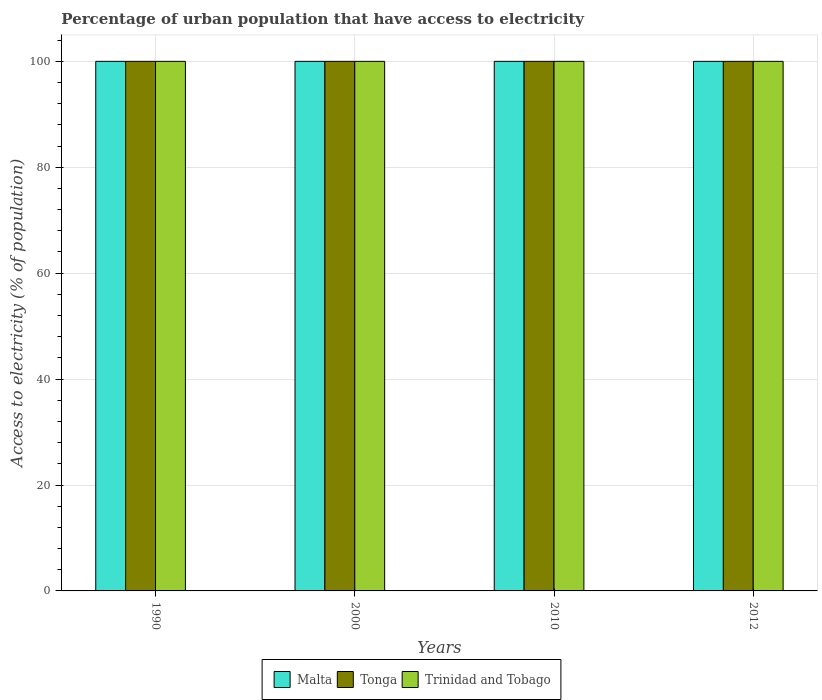How many different coloured bars are there?
Offer a very short reply. 3. What is the percentage of urban population that have access to electricity in Tonga in 1990?
Offer a very short reply. 100. Across all years, what is the maximum percentage of urban population that have access to electricity in Tonga?
Your answer should be very brief. 100. Across all years, what is the minimum percentage of urban population that have access to electricity in Tonga?
Make the answer very short. 100. In which year was the percentage of urban population that have access to electricity in Malta maximum?
Your response must be concise. 1990. What is the total percentage of urban population that have access to electricity in Trinidad and Tobago in the graph?
Provide a short and direct response. 400. In the year 1990, what is the difference between the percentage of urban population that have access to electricity in Tonga and percentage of urban population that have access to electricity in Malta?
Offer a terse response. 0. What is the ratio of the percentage of urban population that have access to electricity in Trinidad and Tobago in 1990 to that in 2000?
Provide a succinct answer. 1. Is the percentage of urban population that have access to electricity in Tonga in 1990 less than that in 2000?
Your answer should be compact. No. What is the difference between the highest and the second highest percentage of urban population that have access to electricity in Trinidad and Tobago?
Make the answer very short. 0. What is the difference between the highest and the lowest percentage of urban population that have access to electricity in Trinidad and Tobago?
Offer a terse response. 0. What does the 3rd bar from the left in 2000 represents?
Provide a short and direct response. Trinidad and Tobago. What does the 3rd bar from the right in 2012 represents?
Offer a very short reply. Malta. Is it the case that in every year, the sum of the percentage of urban population that have access to electricity in Trinidad and Tobago and percentage of urban population that have access to electricity in Tonga is greater than the percentage of urban population that have access to electricity in Malta?
Offer a very short reply. Yes. How many bars are there?
Your answer should be very brief. 12. Are all the bars in the graph horizontal?
Make the answer very short. No. How many years are there in the graph?
Your answer should be compact. 4. Does the graph contain any zero values?
Provide a short and direct response. No. How are the legend labels stacked?
Keep it short and to the point. Horizontal. What is the title of the graph?
Provide a short and direct response. Percentage of urban population that have access to electricity. Does "Low & middle income" appear as one of the legend labels in the graph?
Offer a terse response. No. What is the label or title of the Y-axis?
Ensure brevity in your answer.  Access to electricity (% of population). What is the Access to electricity (% of population) in Tonga in 1990?
Give a very brief answer. 100. What is the Access to electricity (% of population) of Trinidad and Tobago in 1990?
Your response must be concise. 100. What is the Access to electricity (% of population) in Malta in 2000?
Ensure brevity in your answer.  100. What is the Access to electricity (% of population) in Tonga in 2000?
Make the answer very short. 100. What is the Access to electricity (% of population) in Trinidad and Tobago in 2000?
Provide a succinct answer. 100. What is the Access to electricity (% of population) of Trinidad and Tobago in 2012?
Provide a succinct answer. 100. Across all years, what is the maximum Access to electricity (% of population) in Tonga?
Your response must be concise. 100. Across all years, what is the minimum Access to electricity (% of population) of Malta?
Offer a terse response. 100. What is the total Access to electricity (% of population) of Malta in the graph?
Provide a short and direct response. 400. What is the total Access to electricity (% of population) in Tonga in the graph?
Your answer should be compact. 400. What is the total Access to electricity (% of population) in Trinidad and Tobago in the graph?
Provide a succinct answer. 400. What is the difference between the Access to electricity (% of population) in Malta in 1990 and that in 2000?
Make the answer very short. 0. What is the difference between the Access to electricity (% of population) of Tonga in 1990 and that in 2000?
Your answer should be compact. 0. What is the difference between the Access to electricity (% of population) in Trinidad and Tobago in 1990 and that in 2000?
Provide a succinct answer. 0. What is the difference between the Access to electricity (% of population) of Tonga in 1990 and that in 2012?
Keep it short and to the point. 0. What is the difference between the Access to electricity (% of population) of Trinidad and Tobago in 1990 and that in 2012?
Keep it short and to the point. 0. What is the difference between the Access to electricity (% of population) in Malta in 2000 and that in 2010?
Give a very brief answer. 0. What is the difference between the Access to electricity (% of population) in Trinidad and Tobago in 2000 and that in 2010?
Give a very brief answer. 0. What is the difference between the Access to electricity (% of population) of Tonga in 2000 and that in 2012?
Offer a terse response. 0. What is the difference between the Access to electricity (% of population) of Trinidad and Tobago in 2000 and that in 2012?
Your answer should be compact. 0. What is the difference between the Access to electricity (% of population) of Malta in 2010 and that in 2012?
Keep it short and to the point. 0. What is the difference between the Access to electricity (% of population) in Tonga in 2010 and that in 2012?
Make the answer very short. 0. What is the difference between the Access to electricity (% of population) of Malta in 1990 and the Access to electricity (% of population) of Tonga in 2000?
Offer a very short reply. 0. What is the difference between the Access to electricity (% of population) of Malta in 1990 and the Access to electricity (% of population) of Trinidad and Tobago in 2000?
Make the answer very short. 0. What is the difference between the Access to electricity (% of population) in Malta in 1990 and the Access to electricity (% of population) in Tonga in 2010?
Make the answer very short. 0. What is the difference between the Access to electricity (% of population) of Malta in 1990 and the Access to electricity (% of population) of Trinidad and Tobago in 2010?
Your answer should be very brief. 0. What is the difference between the Access to electricity (% of population) of Tonga in 1990 and the Access to electricity (% of population) of Trinidad and Tobago in 2010?
Provide a short and direct response. 0. What is the difference between the Access to electricity (% of population) in Tonga in 1990 and the Access to electricity (% of population) in Trinidad and Tobago in 2012?
Make the answer very short. 0. What is the difference between the Access to electricity (% of population) of Malta in 2000 and the Access to electricity (% of population) of Tonga in 2010?
Ensure brevity in your answer.  0. What is the difference between the Access to electricity (% of population) in Malta in 2000 and the Access to electricity (% of population) in Trinidad and Tobago in 2010?
Make the answer very short. 0. What is the difference between the Access to electricity (% of population) in Tonga in 2000 and the Access to electricity (% of population) in Trinidad and Tobago in 2010?
Your answer should be very brief. 0. What is the difference between the Access to electricity (% of population) in Malta in 2000 and the Access to electricity (% of population) in Tonga in 2012?
Keep it short and to the point. 0. What is the difference between the Access to electricity (% of population) in Malta in 2000 and the Access to electricity (% of population) in Trinidad and Tobago in 2012?
Provide a succinct answer. 0. What is the difference between the Access to electricity (% of population) in Tonga in 2000 and the Access to electricity (% of population) in Trinidad and Tobago in 2012?
Offer a very short reply. 0. What is the difference between the Access to electricity (% of population) of Malta in 2010 and the Access to electricity (% of population) of Tonga in 2012?
Offer a very short reply. 0. What is the difference between the Access to electricity (% of population) of Malta in 2010 and the Access to electricity (% of population) of Trinidad and Tobago in 2012?
Provide a succinct answer. 0. What is the difference between the Access to electricity (% of population) in Tonga in 2010 and the Access to electricity (% of population) in Trinidad and Tobago in 2012?
Offer a terse response. 0. What is the average Access to electricity (% of population) of Malta per year?
Your answer should be compact. 100. What is the average Access to electricity (% of population) of Trinidad and Tobago per year?
Keep it short and to the point. 100. In the year 2000, what is the difference between the Access to electricity (% of population) of Malta and Access to electricity (% of population) of Tonga?
Keep it short and to the point. 0. In the year 2000, what is the difference between the Access to electricity (% of population) of Malta and Access to electricity (% of population) of Trinidad and Tobago?
Provide a succinct answer. 0. In the year 2010, what is the difference between the Access to electricity (% of population) of Malta and Access to electricity (% of population) of Tonga?
Ensure brevity in your answer.  0. In the year 2010, what is the difference between the Access to electricity (% of population) in Tonga and Access to electricity (% of population) in Trinidad and Tobago?
Provide a short and direct response. 0. In the year 2012, what is the difference between the Access to electricity (% of population) of Malta and Access to electricity (% of population) of Trinidad and Tobago?
Offer a terse response. 0. In the year 2012, what is the difference between the Access to electricity (% of population) of Tonga and Access to electricity (% of population) of Trinidad and Tobago?
Offer a terse response. 0. What is the ratio of the Access to electricity (% of population) in Malta in 1990 to that in 2000?
Give a very brief answer. 1. What is the ratio of the Access to electricity (% of population) in Tonga in 1990 to that in 2000?
Your response must be concise. 1. What is the ratio of the Access to electricity (% of population) of Malta in 1990 to that in 2012?
Your answer should be very brief. 1. What is the ratio of the Access to electricity (% of population) in Tonga in 1990 to that in 2012?
Your response must be concise. 1. What is the ratio of the Access to electricity (% of population) in Trinidad and Tobago in 1990 to that in 2012?
Offer a terse response. 1. What is the ratio of the Access to electricity (% of population) of Tonga in 2000 to that in 2012?
Make the answer very short. 1. What is the ratio of the Access to electricity (% of population) of Trinidad and Tobago in 2010 to that in 2012?
Offer a terse response. 1. What is the difference between the highest and the second highest Access to electricity (% of population) in Malta?
Make the answer very short. 0. What is the difference between the highest and the second highest Access to electricity (% of population) in Tonga?
Offer a very short reply. 0. What is the difference between the highest and the lowest Access to electricity (% of population) of Malta?
Provide a succinct answer. 0. 